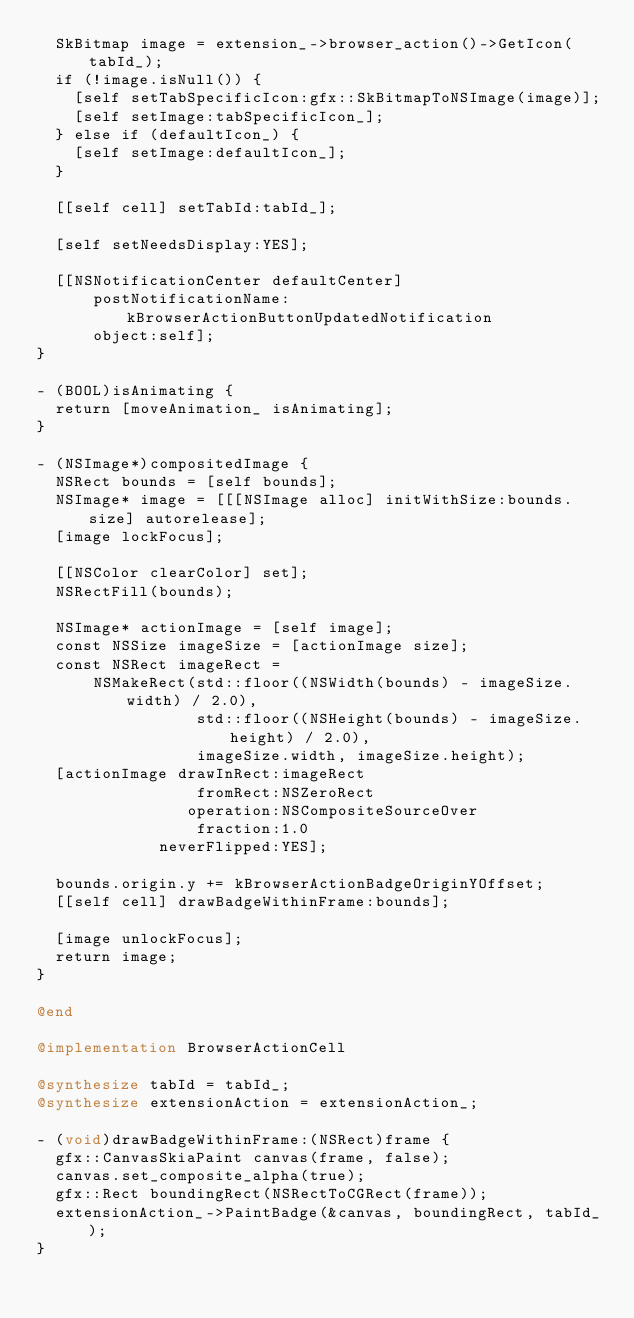<code> <loc_0><loc_0><loc_500><loc_500><_ObjectiveC_>  SkBitmap image = extension_->browser_action()->GetIcon(tabId_);
  if (!image.isNull()) {
    [self setTabSpecificIcon:gfx::SkBitmapToNSImage(image)];
    [self setImage:tabSpecificIcon_];
  } else if (defaultIcon_) {
    [self setImage:defaultIcon_];
  }

  [[self cell] setTabId:tabId_];

  [self setNeedsDisplay:YES];

  [[NSNotificationCenter defaultCenter]
      postNotificationName:kBrowserActionButtonUpdatedNotification
      object:self];
}

- (BOOL)isAnimating {
  return [moveAnimation_ isAnimating];
}

- (NSImage*)compositedImage {
  NSRect bounds = [self bounds];
  NSImage* image = [[[NSImage alloc] initWithSize:bounds.size] autorelease];
  [image lockFocus];

  [[NSColor clearColor] set];
  NSRectFill(bounds);

  NSImage* actionImage = [self image];
  const NSSize imageSize = [actionImage size];
  const NSRect imageRect =
      NSMakeRect(std::floor((NSWidth(bounds) - imageSize.width) / 2.0),
                 std::floor((NSHeight(bounds) - imageSize.height) / 2.0),
                 imageSize.width, imageSize.height);
  [actionImage drawInRect:imageRect
                 fromRect:NSZeroRect
                operation:NSCompositeSourceOver
                 fraction:1.0
             neverFlipped:YES];

  bounds.origin.y += kBrowserActionBadgeOriginYOffset;
  [[self cell] drawBadgeWithinFrame:bounds];

  [image unlockFocus];
  return image;
}

@end

@implementation BrowserActionCell

@synthesize tabId = tabId_;
@synthesize extensionAction = extensionAction_;

- (void)drawBadgeWithinFrame:(NSRect)frame {
  gfx::CanvasSkiaPaint canvas(frame, false);
  canvas.set_composite_alpha(true);
  gfx::Rect boundingRect(NSRectToCGRect(frame));
  extensionAction_->PaintBadge(&canvas, boundingRect, tabId_);
}
</code> 